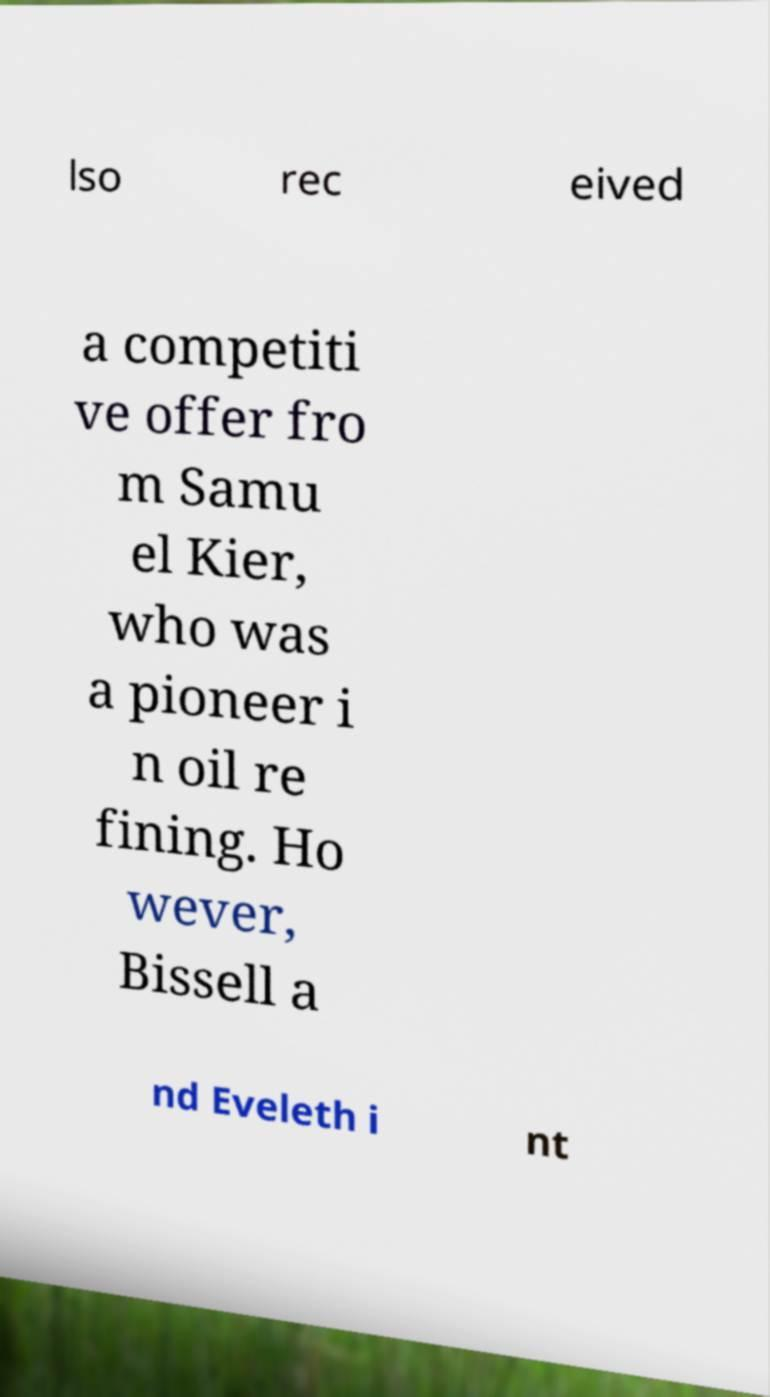Can you accurately transcribe the text from the provided image for me? lso rec eived a competiti ve offer fro m Samu el Kier, who was a pioneer i n oil re fining. Ho wever, Bissell a nd Eveleth i nt 